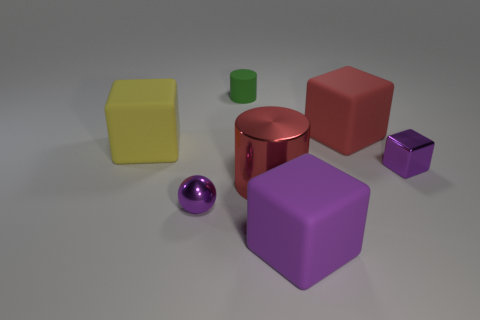The rubber cube that is the same color as the tiny shiny block is what size?
Your answer should be very brief. Large. There is a red matte object; is its shape the same as the purple shiny object that is in front of the metal cylinder?
Your response must be concise. No. What number of purple things are behind the tiny purple ball?
Give a very brief answer. 1. There is a green thing that is on the left side of the metal block; does it have the same shape as the large shiny thing?
Your response must be concise. Yes. What is the color of the cylinder on the right side of the tiny green object?
Your answer should be very brief. Red. There is a big object that is made of the same material as the small purple sphere; what is its shape?
Your response must be concise. Cylinder. Is there anything else of the same color as the small matte cylinder?
Provide a succinct answer. No. Is the number of balls that are left of the yellow rubber block greater than the number of purple shiny balls behind the red matte thing?
Offer a very short reply. No. What number of purple shiny spheres have the same size as the metal block?
Give a very brief answer. 1. Is the number of small purple shiny things that are in front of the large red metallic cylinder less than the number of red metal cylinders that are on the left side of the metal ball?
Ensure brevity in your answer.  No. 